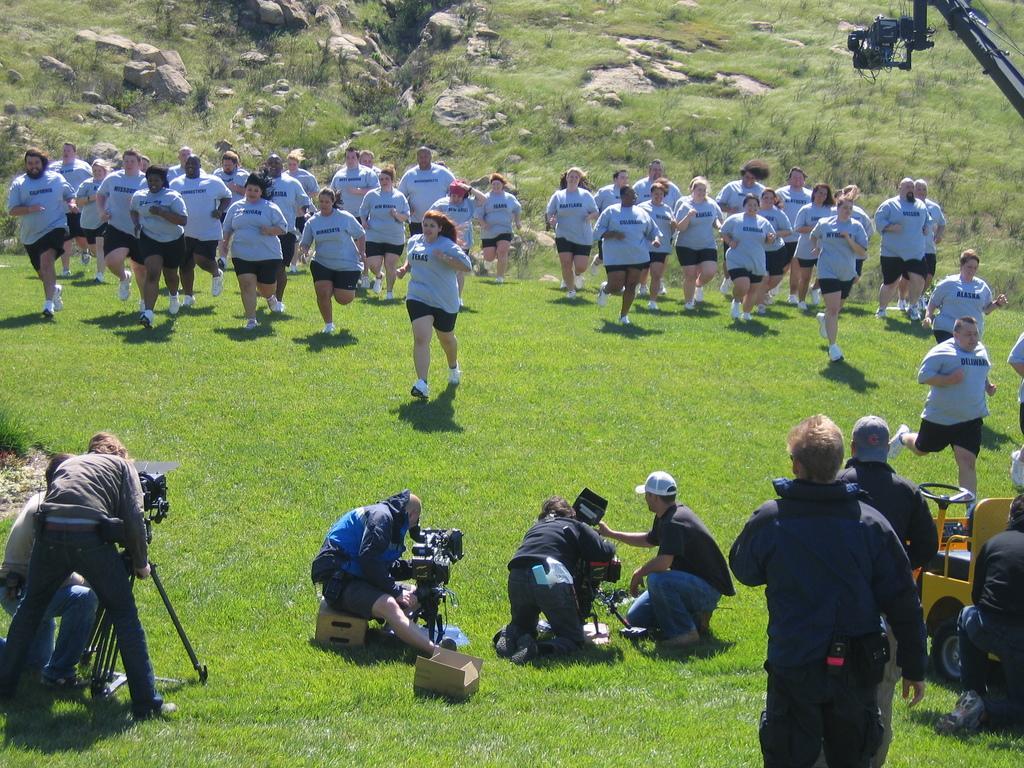Describe this image in one or two sentences. In this image I can see an open grass ground and on it I can see number of people. I can also see few people are sitting, few are standing and most of people are running. I can also see most of people are wearing grey colour t shirts and I can also see something is written on their dresses. On the bottom side of the image I can see few cameras, a box, a stool and a yellow colour vehicle. On the top right side of the image I can see one more camera and in the background I can see number of stones. 